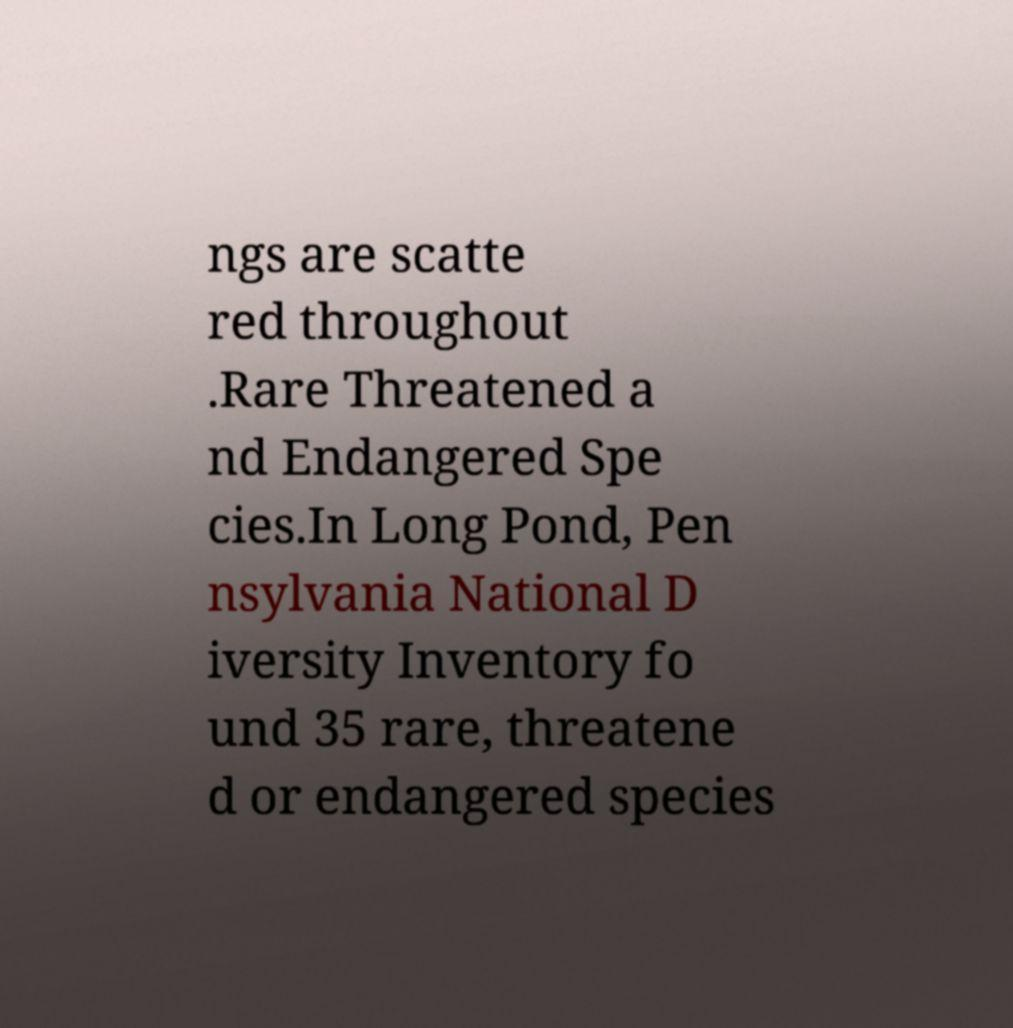Could you assist in decoding the text presented in this image and type it out clearly? ngs are scatte red throughout .Rare Threatened a nd Endangered Spe cies.In Long Pond, Pen nsylvania National D iversity Inventory fo und 35 rare, threatene d or endangered species 